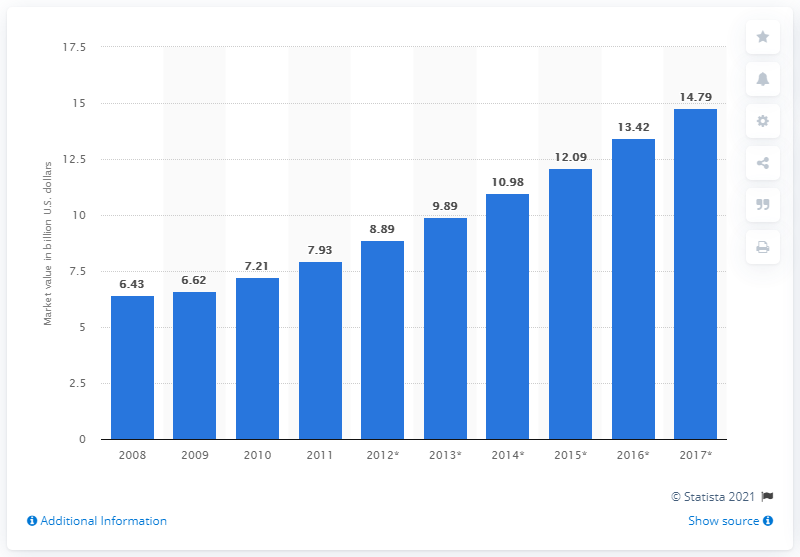Highlight a few significant elements in this photo. In Thailand, the entertainment and media market was expected to reach a value of 14.79 in 2017. In 2011, the entertainment and media market in Thailand was valued at 7.93. 